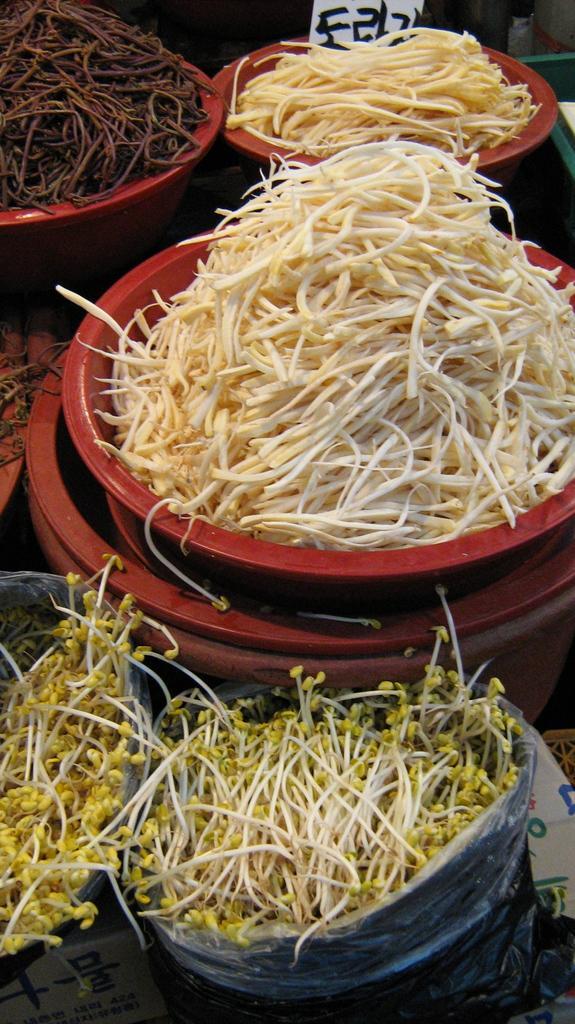Could you give a brief overview of what you see in this image? In the image we can see a plastic cover, in the plastic cover we can see there are sprouts. There are many containers and in the container there are food items. 